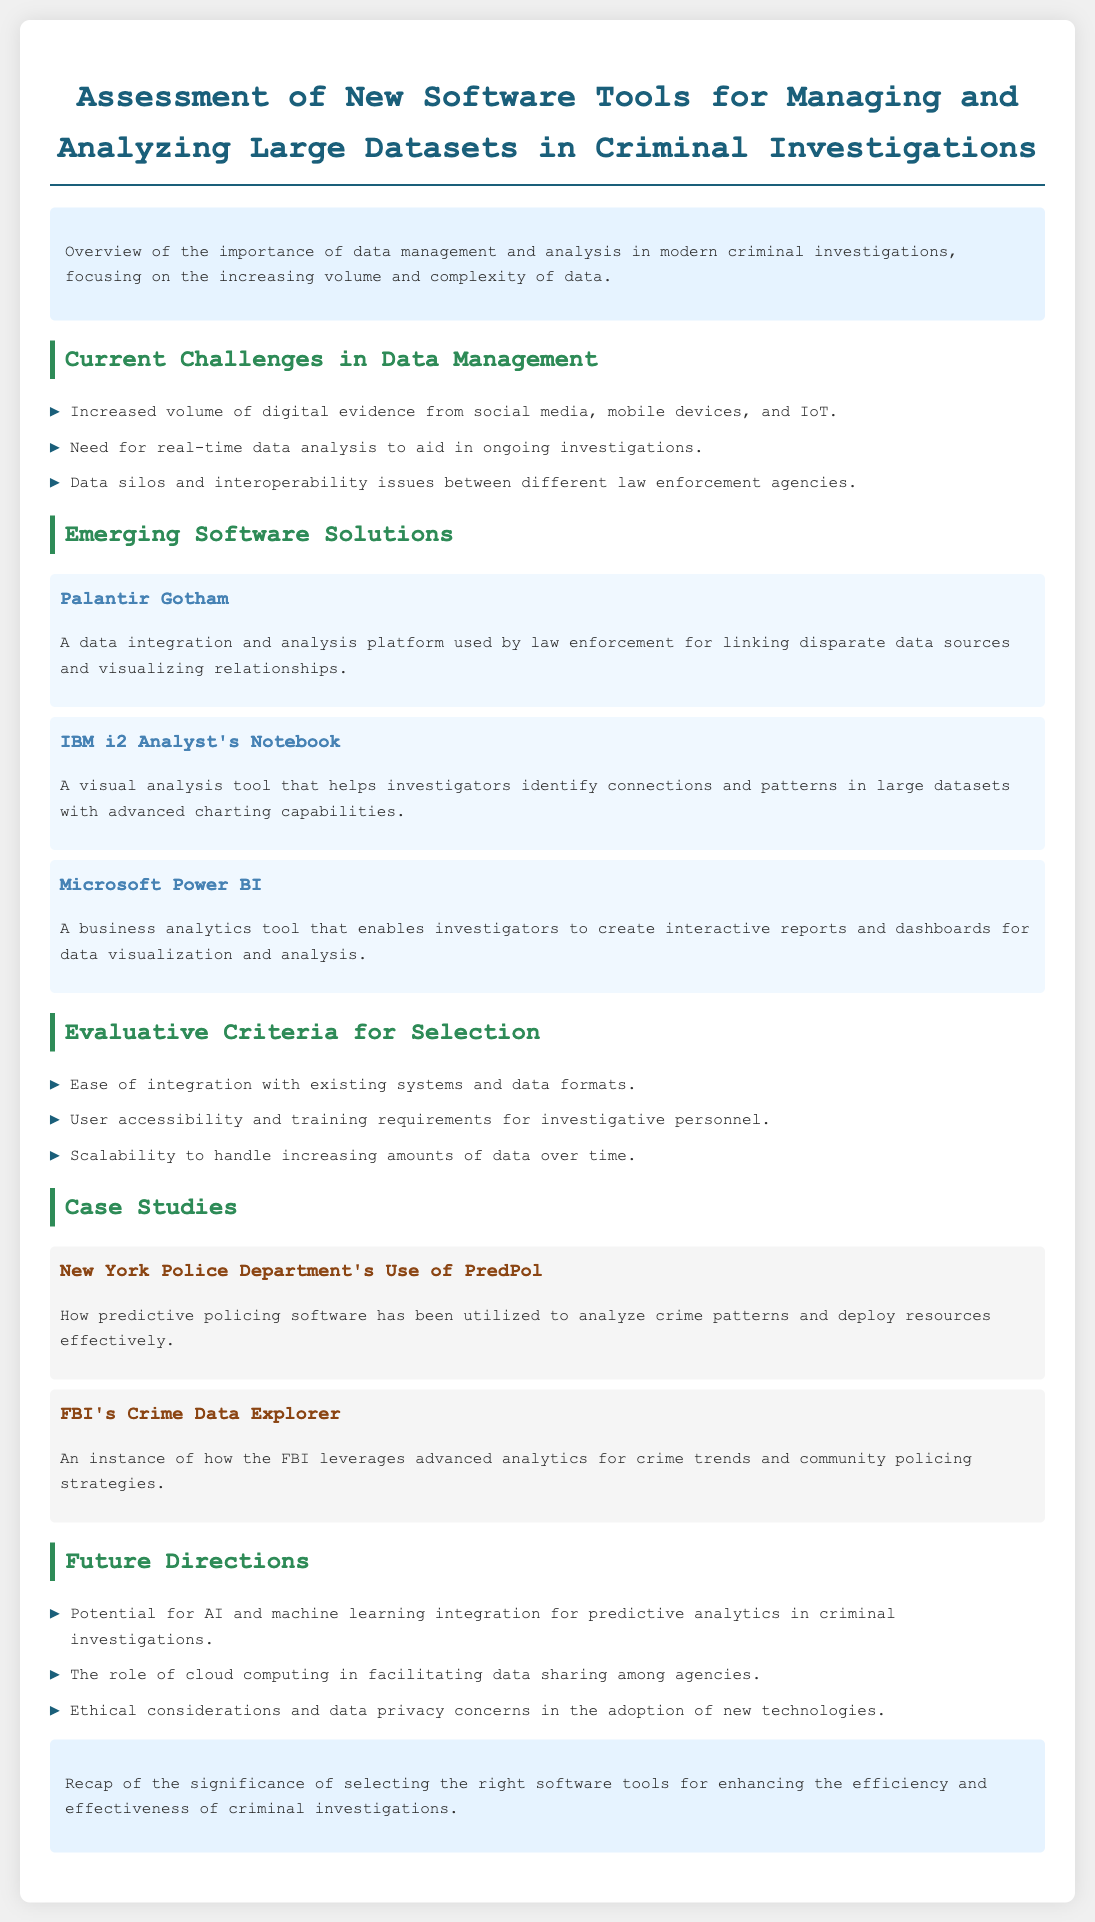What are the current challenges in data management? The document lists challenges including increased volume of digital evidence, need for real-time analysis, and data silos.
Answer: Increased volume, real-time analysis, data silos What is Palantir Gotham? Palantir Gotham is described as a data integration and analysis platform used by law enforcement.
Answer: A data integration and analysis platform What is the purpose of evaluative criteria in software selection? The evaluative criteria help assess software tools based on factors like integration ease and user accessibility.
Answer: Assess software tools How many software tools are listed in the document? The document lists three software tools for managing and analyzing datasets.
Answer: Three What case study discusses predictive policing? The case study focused on predictive policing is from the New York Police Department.
Answer: New York Police Department What future direction involves AI in criminal investigations? The potential for AI and machine learning integration is mentioned as a future direction.
Answer: AI integration What is a primary ethical consideration mentioned in the document? The document highlights data privacy concerns as a significant ethical consideration.
Answer: Data privacy concerns Which software tool enables interactive reports and dashboards? Microsoft Power BI is the tool that enables the creation of interactive reports and dashboards.
Answer: Microsoft Power BI What color is used for section headings in the document? Section headings are formatted with a specific color from the document's CSS style.
Answer: Green 